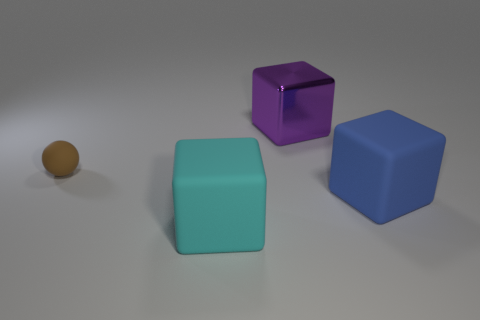Add 2 big blue matte blocks. How many objects exist? 6 Subtract all blocks. How many objects are left? 1 Add 1 large cyan things. How many large cyan things are left? 2 Add 1 cyan matte objects. How many cyan matte objects exist? 2 Subtract 1 cyan cubes. How many objects are left? 3 Subtract all big purple things. Subtract all large blue things. How many objects are left? 2 